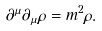<formula> <loc_0><loc_0><loc_500><loc_500>\partial ^ { \mu } \partial _ { \mu } \rho = m ^ { 2 } \rho .</formula> 